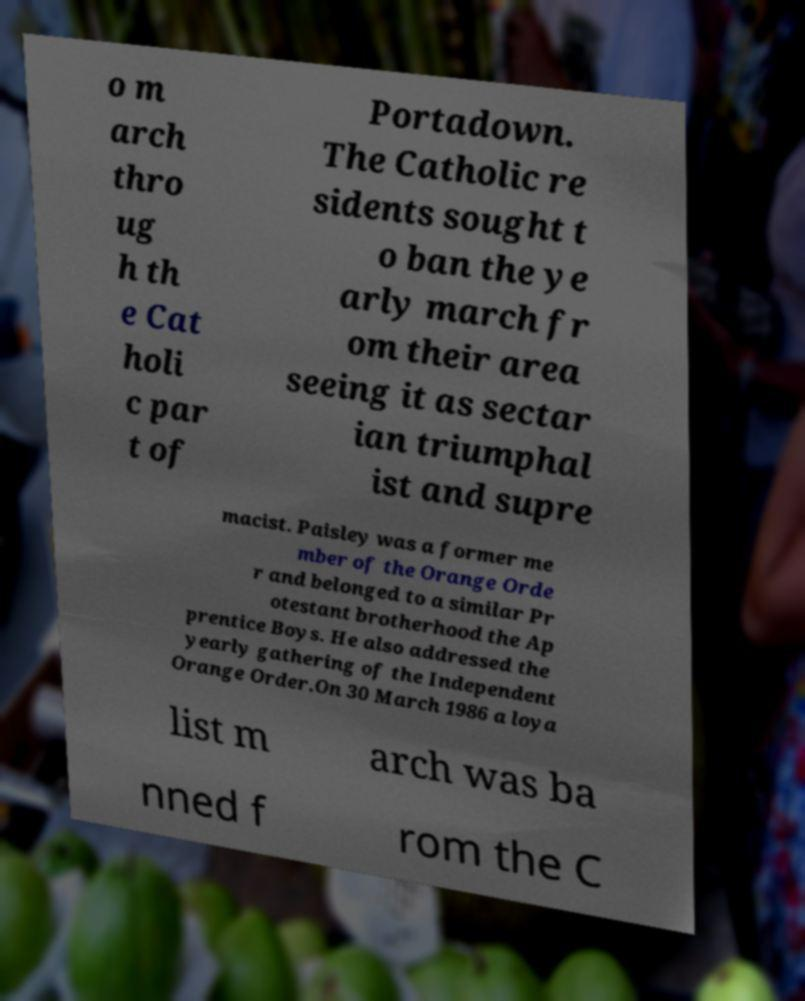Could you assist in decoding the text presented in this image and type it out clearly? o m arch thro ug h th e Cat holi c par t of Portadown. The Catholic re sidents sought t o ban the ye arly march fr om their area seeing it as sectar ian triumphal ist and supre macist. Paisley was a former me mber of the Orange Orde r and belonged to a similar Pr otestant brotherhood the Ap prentice Boys. He also addressed the yearly gathering of the Independent Orange Order.On 30 March 1986 a loya list m arch was ba nned f rom the C 